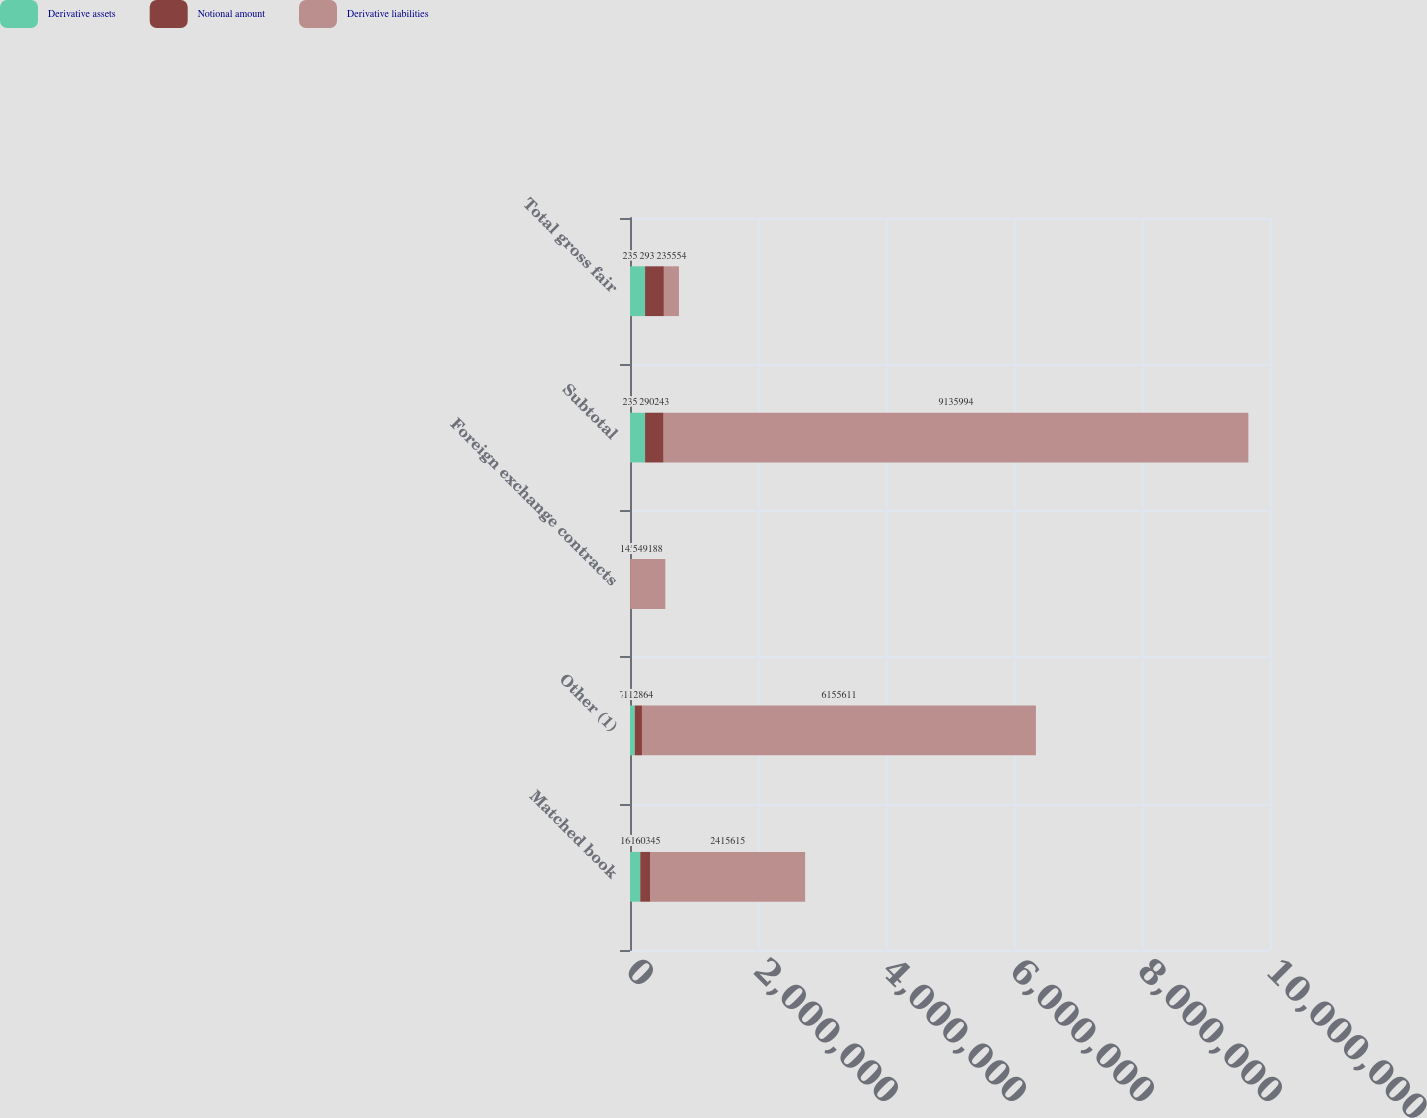Convert chart to OTSL. <chart><loc_0><loc_0><loc_500><loc_500><stacked_bar_chart><ecel><fcel>Matched book<fcel>Other (1)<fcel>Foreign exchange contracts<fcel>Subtotal<fcel>Total gross fair<nl><fcel>Derivative assets<fcel>160345<fcel>74068<fcel>1141<fcel>235554<fcel>235554<nl><fcel>Notional amount<fcel>160345<fcel>112864<fcel>1454<fcel>290243<fcel>293766<nl><fcel>Derivative liabilities<fcel>2.41562e+06<fcel>6.15561e+06<fcel>549188<fcel>9.13599e+06<fcel>235554<nl></chart> 